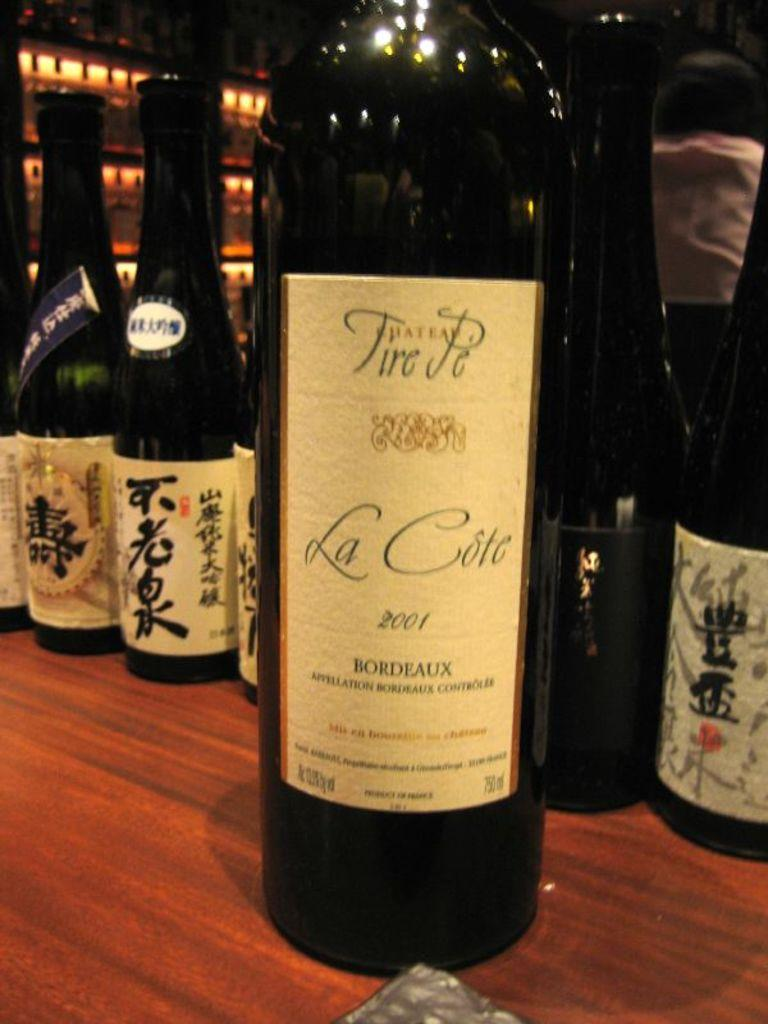<image>
Relay a brief, clear account of the picture shown. Bottle of alcohol that says La Cote on it. 